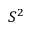<formula> <loc_0><loc_0><loc_500><loc_500>S ^ { 2 }</formula> 